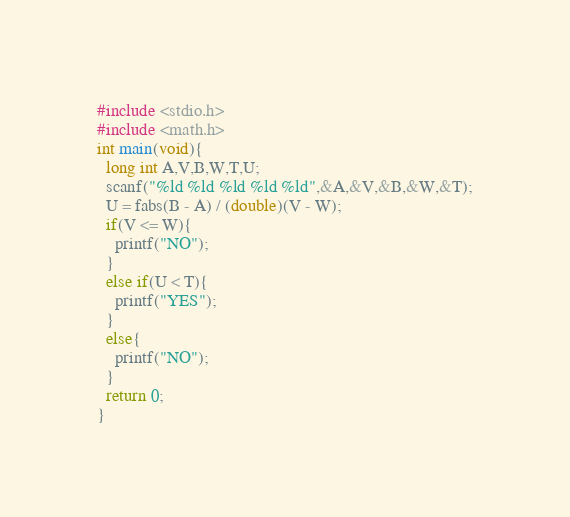Convert code to text. <code><loc_0><loc_0><loc_500><loc_500><_C_>#include <stdio.h>
#include <math.h>
int main(void){
  long int A,V,B,W,T,U;
  scanf("%ld %ld %ld %ld %ld",&A,&V,&B,&W,&T);
  U = fabs(B - A) / (double)(V - W);
  if(V <= W){
    printf("NO");
  }
  else if(U < T){
    printf("YES");
  }
  else{
    printf("NO");
  }
  return 0;
}</code> 